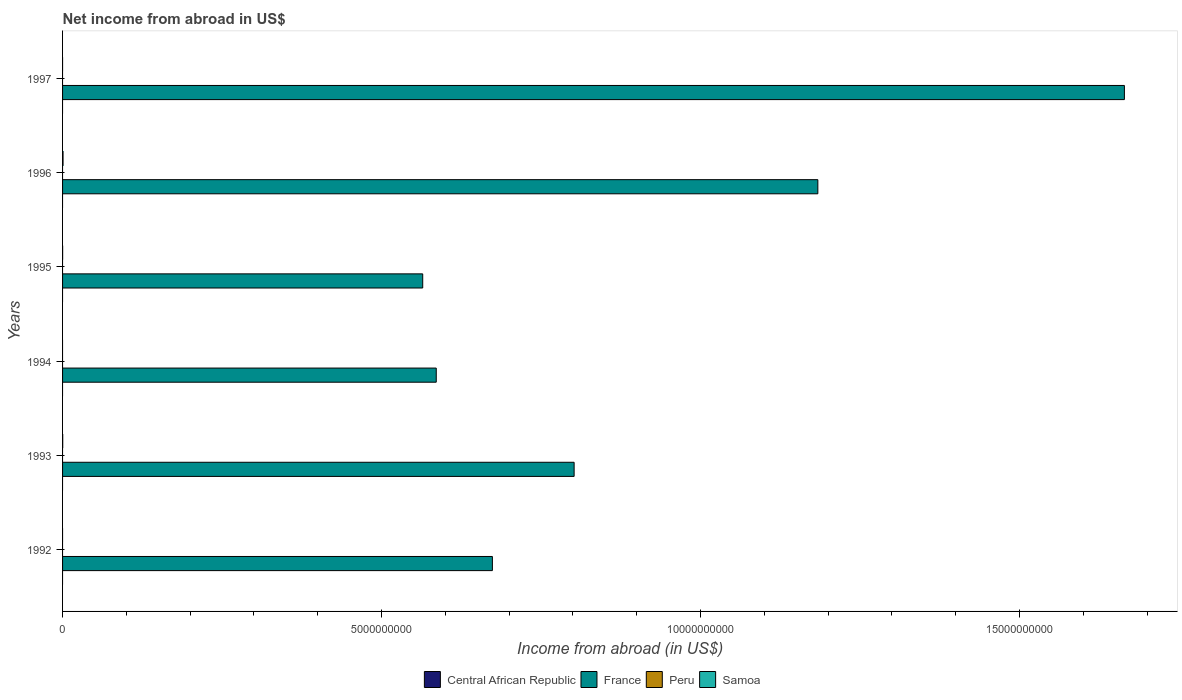How many different coloured bars are there?
Your answer should be compact. 2. Are the number of bars per tick equal to the number of legend labels?
Your answer should be compact. No. Are the number of bars on each tick of the Y-axis equal?
Offer a terse response. No. How many bars are there on the 6th tick from the bottom?
Give a very brief answer. 1. What is the net income from abroad in Central African Republic in 1992?
Give a very brief answer. 0. Across all years, what is the maximum net income from abroad in France?
Offer a terse response. 1.66e+1. In which year was the net income from abroad in Samoa maximum?
Provide a succinct answer. 1996. What is the total net income from abroad in Samoa in the graph?
Your answer should be compact. 1.07e+07. What is the difference between the net income from abroad in Samoa in 1993 and that in 1996?
Make the answer very short. -5.20e+06. What is the difference between the net income from abroad in Central African Republic in 1997 and the net income from abroad in Peru in 1995?
Your answer should be very brief. 0. What is the average net income from abroad in Central African Republic per year?
Your response must be concise. 0. In how many years, is the net income from abroad in Central African Republic greater than 4000000000 US$?
Offer a terse response. 0. What is the ratio of the net income from abroad in France in 1992 to that in 1997?
Your answer should be very brief. 0.4. What is the difference between the highest and the second highest net income from abroad in Samoa?
Your answer should be compact. 5.20e+06. What is the difference between the highest and the lowest net income from abroad in Samoa?
Provide a succinct answer. 7.50e+06. Is the sum of the net income from abroad in France in 1994 and 1995 greater than the maximum net income from abroad in Samoa across all years?
Your answer should be very brief. Yes. Is it the case that in every year, the sum of the net income from abroad in Samoa and net income from abroad in France is greater than the sum of net income from abroad in Peru and net income from abroad in Central African Republic?
Keep it short and to the point. Yes. Is it the case that in every year, the sum of the net income from abroad in Peru and net income from abroad in Central African Republic is greater than the net income from abroad in Samoa?
Ensure brevity in your answer.  No. Are the values on the major ticks of X-axis written in scientific E-notation?
Offer a terse response. No. Does the graph contain any zero values?
Your response must be concise. Yes. Does the graph contain grids?
Make the answer very short. No. Where does the legend appear in the graph?
Make the answer very short. Bottom center. How many legend labels are there?
Your answer should be very brief. 4. How are the legend labels stacked?
Give a very brief answer. Horizontal. What is the title of the graph?
Offer a very short reply. Net income from abroad in US$. What is the label or title of the X-axis?
Make the answer very short. Income from abroad (in US$). What is the label or title of the Y-axis?
Provide a short and direct response. Years. What is the Income from abroad (in US$) in Central African Republic in 1992?
Offer a very short reply. 0. What is the Income from abroad (in US$) of France in 1992?
Make the answer very short. 6.74e+09. What is the Income from abroad (in US$) in Peru in 1992?
Provide a short and direct response. 0. What is the Income from abroad (in US$) of France in 1993?
Give a very brief answer. 8.02e+09. What is the Income from abroad (in US$) of Peru in 1993?
Your answer should be compact. 0. What is the Income from abroad (in US$) in Samoa in 1993?
Make the answer very short. 2.30e+06. What is the Income from abroad (in US$) of France in 1994?
Ensure brevity in your answer.  5.86e+09. What is the Income from abroad (in US$) of Central African Republic in 1995?
Ensure brevity in your answer.  0. What is the Income from abroad (in US$) in France in 1995?
Make the answer very short. 5.64e+09. What is the Income from abroad (in US$) of Central African Republic in 1996?
Ensure brevity in your answer.  0. What is the Income from abroad (in US$) in France in 1996?
Keep it short and to the point. 1.18e+1. What is the Income from abroad (in US$) in Peru in 1996?
Provide a succinct answer. 0. What is the Income from abroad (in US$) of Samoa in 1996?
Provide a succinct answer. 7.50e+06. What is the Income from abroad (in US$) of Central African Republic in 1997?
Provide a short and direct response. 0. What is the Income from abroad (in US$) in France in 1997?
Your response must be concise. 1.66e+1. What is the Income from abroad (in US$) of Peru in 1997?
Give a very brief answer. 0. Across all years, what is the maximum Income from abroad (in US$) of France?
Offer a terse response. 1.66e+1. Across all years, what is the maximum Income from abroad (in US$) in Samoa?
Provide a succinct answer. 7.50e+06. Across all years, what is the minimum Income from abroad (in US$) of France?
Offer a very short reply. 5.64e+09. What is the total Income from abroad (in US$) of France in the graph?
Make the answer very short. 5.47e+1. What is the total Income from abroad (in US$) of Samoa in the graph?
Your answer should be very brief. 1.07e+07. What is the difference between the Income from abroad (in US$) of France in 1992 and that in 1993?
Provide a succinct answer. -1.28e+09. What is the difference between the Income from abroad (in US$) in France in 1992 and that in 1994?
Ensure brevity in your answer.  8.80e+08. What is the difference between the Income from abroad (in US$) of France in 1992 and that in 1995?
Keep it short and to the point. 1.09e+09. What is the difference between the Income from abroad (in US$) in France in 1992 and that in 1996?
Offer a terse response. -5.10e+09. What is the difference between the Income from abroad (in US$) in France in 1992 and that in 1997?
Your answer should be very brief. -9.91e+09. What is the difference between the Income from abroad (in US$) in France in 1993 and that in 1994?
Give a very brief answer. 2.16e+09. What is the difference between the Income from abroad (in US$) in France in 1993 and that in 1995?
Give a very brief answer. 2.37e+09. What is the difference between the Income from abroad (in US$) of Samoa in 1993 and that in 1995?
Keep it short and to the point. 1.40e+06. What is the difference between the Income from abroad (in US$) of France in 1993 and that in 1996?
Give a very brief answer. -3.82e+09. What is the difference between the Income from abroad (in US$) of Samoa in 1993 and that in 1996?
Your answer should be compact. -5.20e+06. What is the difference between the Income from abroad (in US$) of France in 1993 and that in 1997?
Keep it short and to the point. -8.62e+09. What is the difference between the Income from abroad (in US$) of France in 1994 and that in 1995?
Offer a very short reply. 2.12e+08. What is the difference between the Income from abroad (in US$) in France in 1994 and that in 1996?
Make the answer very short. -5.98e+09. What is the difference between the Income from abroad (in US$) of France in 1994 and that in 1997?
Keep it short and to the point. -1.08e+1. What is the difference between the Income from abroad (in US$) of France in 1995 and that in 1996?
Your answer should be very brief. -6.19e+09. What is the difference between the Income from abroad (in US$) in Samoa in 1995 and that in 1996?
Your answer should be very brief. -6.60e+06. What is the difference between the Income from abroad (in US$) of France in 1995 and that in 1997?
Ensure brevity in your answer.  -1.10e+1. What is the difference between the Income from abroad (in US$) in France in 1996 and that in 1997?
Provide a short and direct response. -4.80e+09. What is the difference between the Income from abroad (in US$) of France in 1992 and the Income from abroad (in US$) of Samoa in 1993?
Offer a very short reply. 6.73e+09. What is the difference between the Income from abroad (in US$) in France in 1992 and the Income from abroad (in US$) in Samoa in 1995?
Make the answer very short. 6.74e+09. What is the difference between the Income from abroad (in US$) in France in 1992 and the Income from abroad (in US$) in Samoa in 1996?
Keep it short and to the point. 6.73e+09. What is the difference between the Income from abroad (in US$) in France in 1993 and the Income from abroad (in US$) in Samoa in 1995?
Keep it short and to the point. 8.02e+09. What is the difference between the Income from abroad (in US$) in France in 1993 and the Income from abroad (in US$) in Samoa in 1996?
Provide a short and direct response. 8.01e+09. What is the difference between the Income from abroad (in US$) of France in 1994 and the Income from abroad (in US$) of Samoa in 1995?
Ensure brevity in your answer.  5.86e+09. What is the difference between the Income from abroad (in US$) of France in 1994 and the Income from abroad (in US$) of Samoa in 1996?
Offer a terse response. 5.85e+09. What is the difference between the Income from abroad (in US$) in France in 1995 and the Income from abroad (in US$) in Samoa in 1996?
Give a very brief answer. 5.64e+09. What is the average Income from abroad (in US$) in France per year?
Provide a succinct answer. 9.12e+09. What is the average Income from abroad (in US$) in Peru per year?
Give a very brief answer. 0. What is the average Income from abroad (in US$) in Samoa per year?
Provide a short and direct response. 1.78e+06. In the year 1993, what is the difference between the Income from abroad (in US$) of France and Income from abroad (in US$) of Samoa?
Provide a short and direct response. 8.02e+09. In the year 1995, what is the difference between the Income from abroad (in US$) in France and Income from abroad (in US$) in Samoa?
Offer a very short reply. 5.64e+09. In the year 1996, what is the difference between the Income from abroad (in US$) of France and Income from abroad (in US$) of Samoa?
Offer a terse response. 1.18e+1. What is the ratio of the Income from abroad (in US$) of France in 1992 to that in 1993?
Provide a short and direct response. 0.84. What is the ratio of the Income from abroad (in US$) of France in 1992 to that in 1994?
Ensure brevity in your answer.  1.15. What is the ratio of the Income from abroad (in US$) in France in 1992 to that in 1995?
Offer a terse response. 1.19. What is the ratio of the Income from abroad (in US$) of France in 1992 to that in 1996?
Your answer should be very brief. 0.57. What is the ratio of the Income from abroad (in US$) of France in 1992 to that in 1997?
Give a very brief answer. 0.4. What is the ratio of the Income from abroad (in US$) in France in 1993 to that in 1994?
Provide a short and direct response. 1.37. What is the ratio of the Income from abroad (in US$) of France in 1993 to that in 1995?
Provide a short and direct response. 1.42. What is the ratio of the Income from abroad (in US$) of Samoa in 1993 to that in 1995?
Give a very brief answer. 2.55. What is the ratio of the Income from abroad (in US$) of France in 1993 to that in 1996?
Make the answer very short. 0.68. What is the ratio of the Income from abroad (in US$) in Samoa in 1993 to that in 1996?
Ensure brevity in your answer.  0.31. What is the ratio of the Income from abroad (in US$) of France in 1993 to that in 1997?
Your response must be concise. 0.48. What is the ratio of the Income from abroad (in US$) in France in 1994 to that in 1995?
Offer a very short reply. 1.04. What is the ratio of the Income from abroad (in US$) in France in 1994 to that in 1996?
Keep it short and to the point. 0.49. What is the ratio of the Income from abroad (in US$) in France in 1994 to that in 1997?
Offer a very short reply. 0.35. What is the ratio of the Income from abroad (in US$) of France in 1995 to that in 1996?
Your response must be concise. 0.48. What is the ratio of the Income from abroad (in US$) of Samoa in 1995 to that in 1996?
Offer a very short reply. 0.12. What is the ratio of the Income from abroad (in US$) of France in 1995 to that in 1997?
Your answer should be compact. 0.34. What is the ratio of the Income from abroad (in US$) of France in 1996 to that in 1997?
Make the answer very short. 0.71. What is the difference between the highest and the second highest Income from abroad (in US$) of France?
Offer a very short reply. 4.80e+09. What is the difference between the highest and the second highest Income from abroad (in US$) in Samoa?
Offer a very short reply. 5.20e+06. What is the difference between the highest and the lowest Income from abroad (in US$) of France?
Keep it short and to the point. 1.10e+1. What is the difference between the highest and the lowest Income from abroad (in US$) in Samoa?
Offer a terse response. 7.50e+06. 